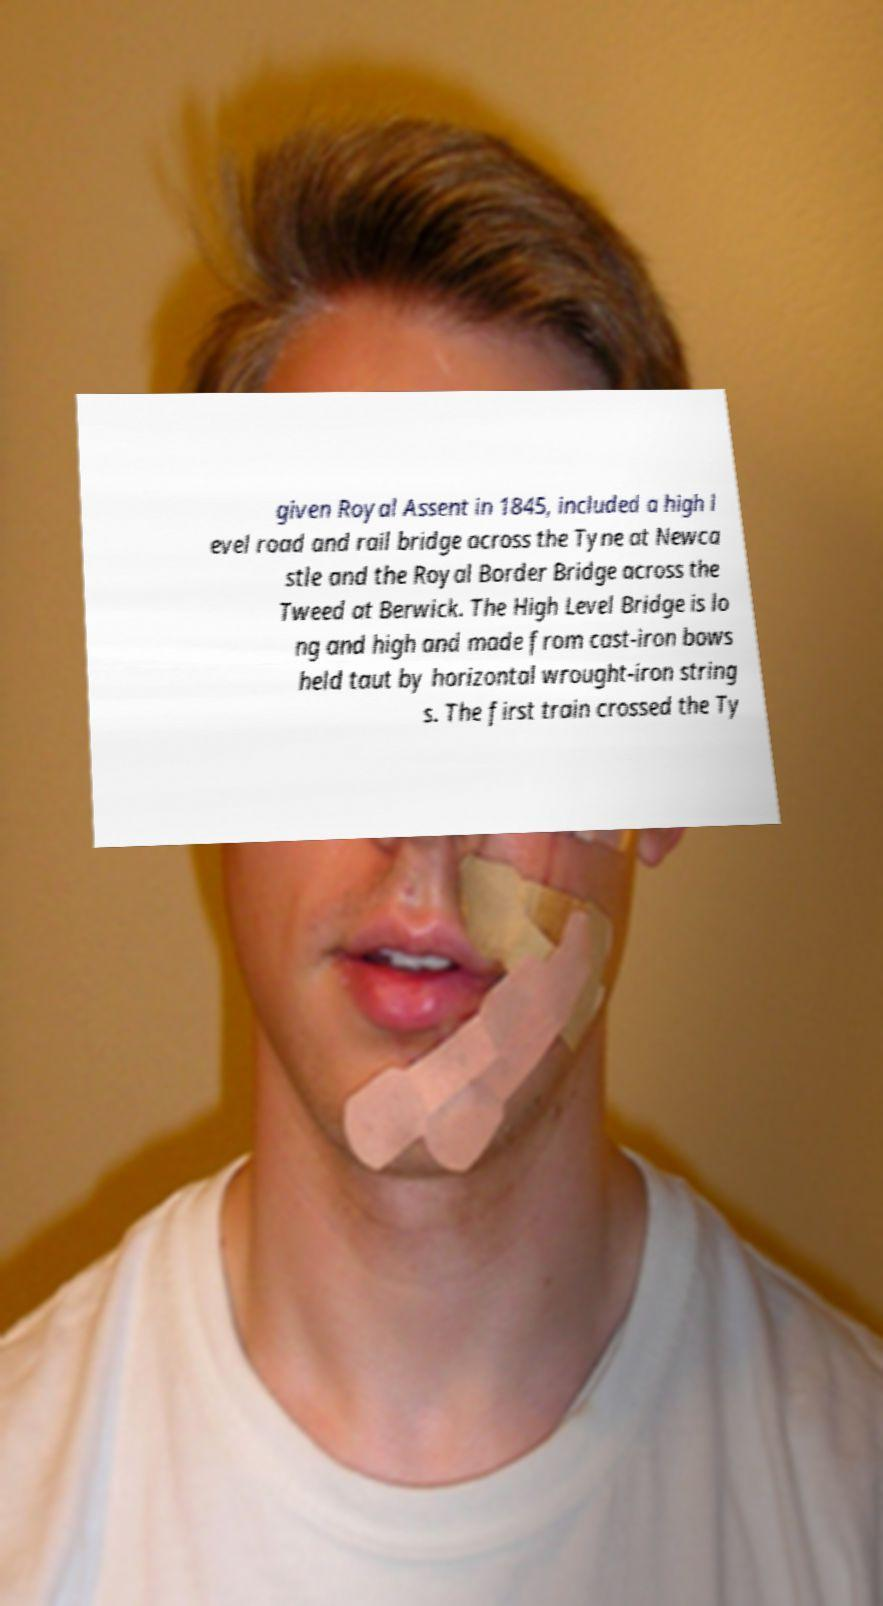Can you accurately transcribe the text from the provided image for me? given Royal Assent in 1845, included a high l evel road and rail bridge across the Tyne at Newca stle and the Royal Border Bridge across the Tweed at Berwick. The High Level Bridge is lo ng and high and made from cast-iron bows held taut by horizontal wrought-iron string s. The first train crossed the Ty 